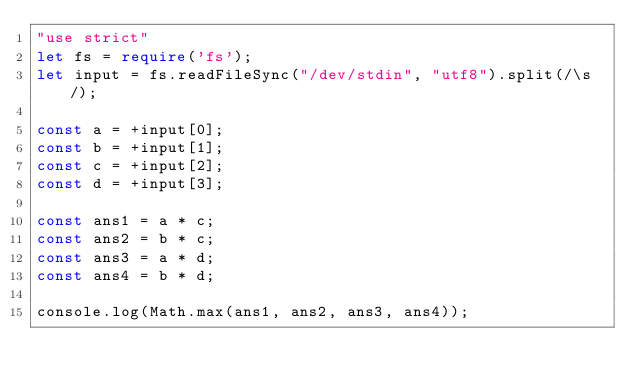<code> <loc_0><loc_0><loc_500><loc_500><_TypeScript_>"use strict"
let fs = require('fs');
let input = fs.readFileSync("/dev/stdin", "utf8").split(/\s/);

const a = +input[0];
const b = +input[1];
const c = +input[2];
const d = +input[3];

const ans1 = a * c;
const ans2 = b * c;
const ans3 = a * d;
const ans4 = b * d;

console.log(Math.max(ans1, ans2, ans3, ans4));</code> 